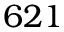<formula> <loc_0><loc_0><loc_500><loc_500>6 2 1</formula> 